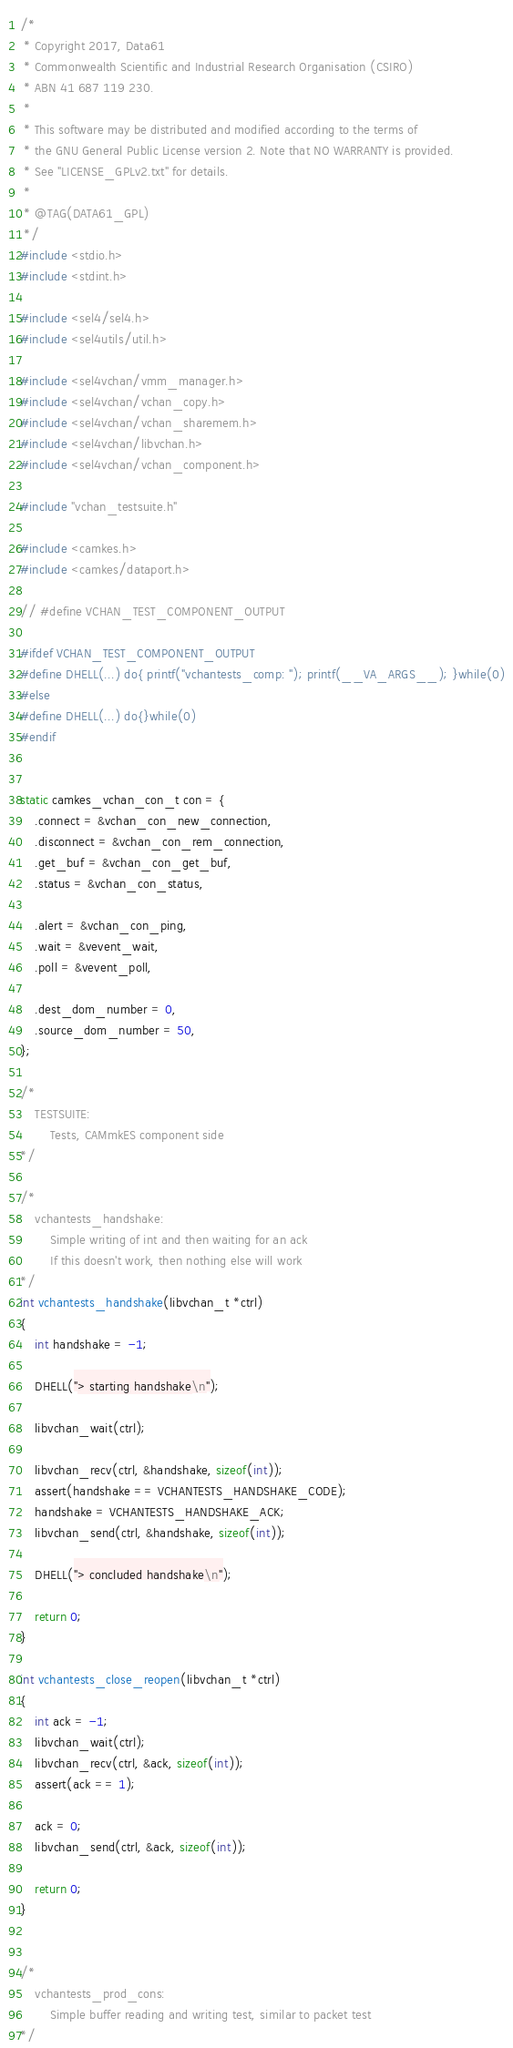Convert code to text. <code><loc_0><loc_0><loc_500><loc_500><_C_>/*
 * Copyright 2017, Data61
 * Commonwealth Scientific and Industrial Research Organisation (CSIRO)
 * ABN 41 687 119 230.
 *
 * This software may be distributed and modified according to the terms of
 * the GNU General Public License version 2. Note that NO WARRANTY is provided.
 * See "LICENSE_GPLv2.txt" for details.
 *
 * @TAG(DATA61_GPL)
 */
#include <stdio.h>
#include <stdint.h>

#include <sel4/sel4.h>
#include <sel4utils/util.h>

#include <sel4vchan/vmm_manager.h>
#include <sel4vchan/vchan_copy.h>
#include <sel4vchan/vchan_sharemem.h>
#include <sel4vchan/libvchan.h>
#include <sel4vchan/vchan_component.h>

#include "vchan_testsuite.h"

#include <camkes.h>
#include <camkes/dataport.h>

// #define VCHAN_TEST_COMPONENT_OUTPUT

#ifdef VCHAN_TEST_COMPONENT_OUTPUT
#define DHELL(...) do{ printf("vchantests_comp: "); printf(__VA_ARGS__); }while(0)
#else
#define DHELL(...) do{}while(0)
#endif


static camkes_vchan_con_t con = {
    .connect = &vchan_con_new_connection,
    .disconnect = &vchan_con_rem_connection,
    .get_buf = &vchan_con_get_buf,
    .status = &vchan_con_status,

    .alert = &vchan_con_ping,
    .wait = &vevent_wait,
    .poll = &vevent_poll,

    .dest_dom_number = 0,
    .source_dom_number = 50,
};

/*
    TESTSUITE:
        Tests, CAMmkES component side
*/

/*
    vchantests_handshake:
        Simple writing of int and then waiting for an ack
        If this doesn't work, then nothing else will work
*/
int vchantests_handshake(libvchan_t *ctrl)
{
    int handshake = -1;

    DHELL("> starting handshake\n");

    libvchan_wait(ctrl);

    libvchan_recv(ctrl, &handshake, sizeof(int));
    assert(handshake == VCHANTESTS_HANDSHAKE_CODE);
    handshake = VCHANTESTS_HANDSHAKE_ACK;
    libvchan_send(ctrl, &handshake, sizeof(int));

    DHELL("> concluded handshake\n");

    return 0;
}

int vchantests_close_reopen(libvchan_t *ctrl)
{
    int ack = -1;
    libvchan_wait(ctrl);
    libvchan_recv(ctrl, &ack, sizeof(int));
    assert(ack == 1);

    ack = 0;
    libvchan_send(ctrl, &ack, sizeof(int));

    return 0;
}


/*
    vchantests_prod_cons:
        Simple buffer reading and writing test, similar to packet test
*/</code> 